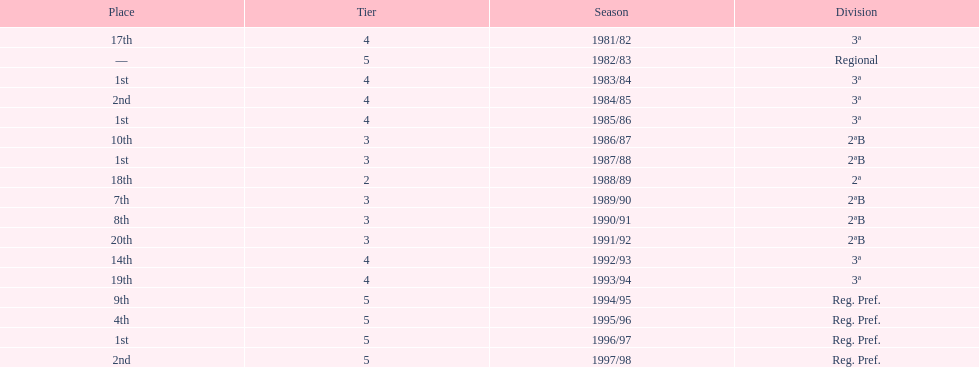How many seasons are shown in this chart? 17. 